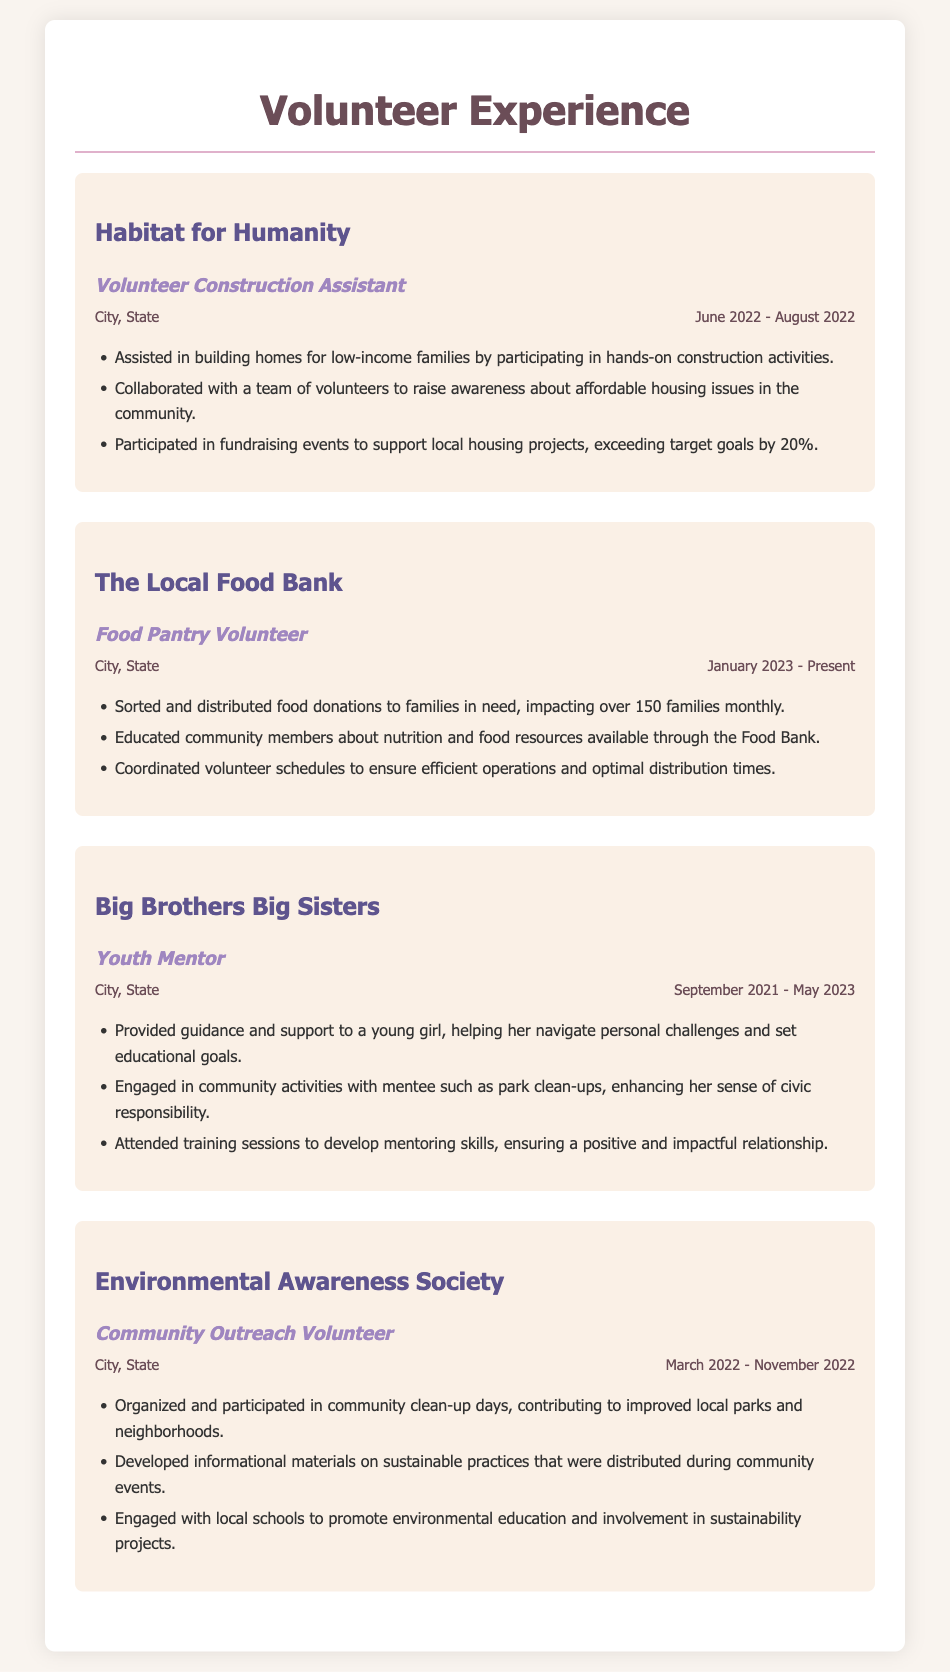What is the name of the first organization listed? The document lists "Habitat for Humanity" as the first volunteer organization.
Answer: Habitat for Humanity What is the position held at The Local Food Bank? The document states that the position held is "Food Pantry Volunteer."
Answer: Food Pantry Volunteer How many families are impacted monthly by the food distribution? The document indicates that over "150 families" are impacted monthly by the food pantry volunteer work.
Answer: 150 families What did the youth mentor help the young girl to set? The document mentions helping the mentee set "educational goals."
Answer: educational goals When did the volunteering at Environmental Awareness Society take place? The document states the timeline for volunteering was "March 2022 - November 2022."
Answer: March 2022 - November 2022 Which project included coordinating volunteer schedules? The coordination of volunteer schedules is part of the duties at The Local Food Bank.
Answer: The Local Food Bank What was the fundraising achievement at Habitat for Humanity? The document highlights that fundraising efforts exceeded target goals by "20%".
Answer: 20% How long did the youth mentoring role last? The document indicates that the youth mentoring role lasted from "September 2021 - May 2023."
Answer: September 2021 - May 2023 What type of events were organized by the Environmental Awareness Society? The document mentions organizing "community clean-up days."
Answer: community clean-up days 